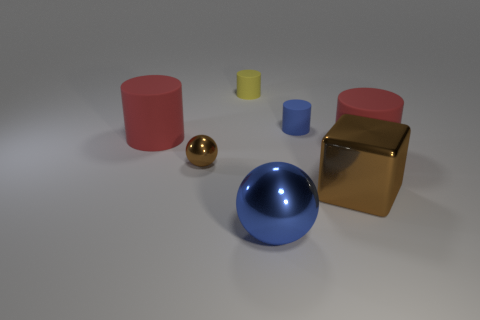Add 1 small gray matte cubes. How many objects exist? 8 Subtract all yellow cylinders. How many cylinders are left? 3 Subtract all small yellow rubber cylinders. How many cylinders are left? 3 Subtract all gray cylinders. Subtract all brown balls. How many cylinders are left? 4 Subtract all cylinders. How many objects are left? 3 Subtract 0 cyan cylinders. How many objects are left? 7 Subtract all big balls. Subtract all brown matte cylinders. How many objects are left? 6 Add 1 brown metal balls. How many brown metal balls are left? 2 Add 5 large yellow metallic blocks. How many large yellow metallic blocks exist? 5 